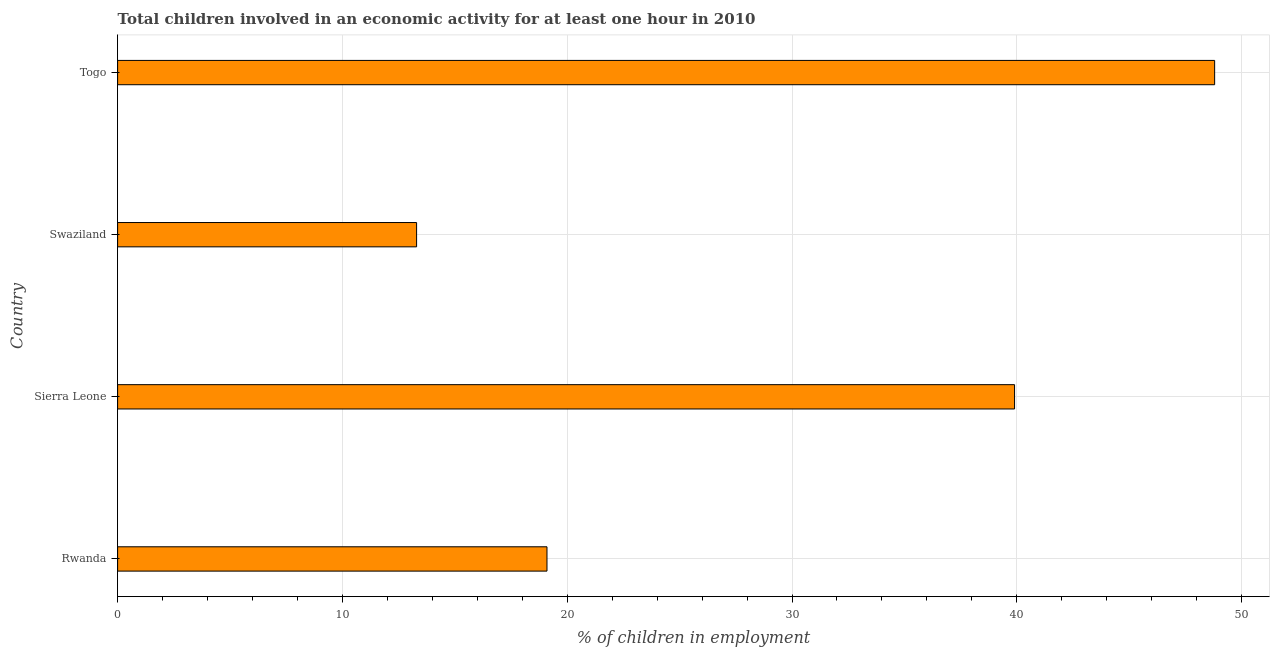Does the graph contain grids?
Ensure brevity in your answer.  Yes. What is the title of the graph?
Offer a terse response. Total children involved in an economic activity for at least one hour in 2010. What is the label or title of the X-axis?
Ensure brevity in your answer.  % of children in employment. Across all countries, what is the maximum percentage of children in employment?
Give a very brief answer. 48.8. In which country was the percentage of children in employment maximum?
Your response must be concise. Togo. In which country was the percentage of children in employment minimum?
Keep it short and to the point. Swaziland. What is the sum of the percentage of children in employment?
Provide a succinct answer. 121.1. What is the average percentage of children in employment per country?
Give a very brief answer. 30.27. What is the median percentage of children in employment?
Provide a short and direct response. 29.5. What is the ratio of the percentage of children in employment in Rwanda to that in Sierra Leone?
Keep it short and to the point. 0.48. Is the difference between the percentage of children in employment in Rwanda and Togo greater than the difference between any two countries?
Ensure brevity in your answer.  No. Is the sum of the percentage of children in employment in Swaziland and Togo greater than the maximum percentage of children in employment across all countries?
Offer a very short reply. Yes. What is the difference between the highest and the lowest percentage of children in employment?
Make the answer very short. 35.5. How many bars are there?
Provide a short and direct response. 4. How many countries are there in the graph?
Your answer should be very brief. 4. What is the difference between two consecutive major ticks on the X-axis?
Give a very brief answer. 10. What is the % of children in employment in Rwanda?
Offer a terse response. 19.1. What is the % of children in employment in Sierra Leone?
Provide a succinct answer. 39.9. What is the % of children in employment in Togo?
Give a very brief answer. 48.8. What is the difference between the % of children in employment in Rwanda and Sierra Leone?
Ensure brevity in your answer.  -20.8. What is the difference between the % of children in employment in Rwanda and Swaziland?
Keep it short and to the point. 5.8. What is the difference between the % of children in employment in Rwanda and Togo?
Your answer should be compact. -29.7. What is the difference between the % of children in employment in Sierra Leone and Swaziland?
Ensure brevity in your answer.  26.6. What is the difference between the % of children in employment in Swaziland and Togo?
Offer a very short reply. -35.5. What is the ratio of the % of children in employment in Rwanda to that in Sierra Leone?
Offer a very short reply. 0.48. What is the ratio of the % of children in employment in Rwanda to that in Swaziland?
Give a very brief answer. 1.44. What is the ratio of the % of children in employment in Rwanda to that in Togo?
Your answer should be very brief. 0.39. What is the ratio of the % of children in employment in Sierra Leone to that in Swaziland?
Your answer should be compact. 3. What is the ratio of the % of children in employment in Sierra Leone to that in Togo?
Provide a succinct answer. 0.82. What is the ratio of the % of children in employment in Swaziland to that in Togo?
Offer a very short reply. 0.27. 